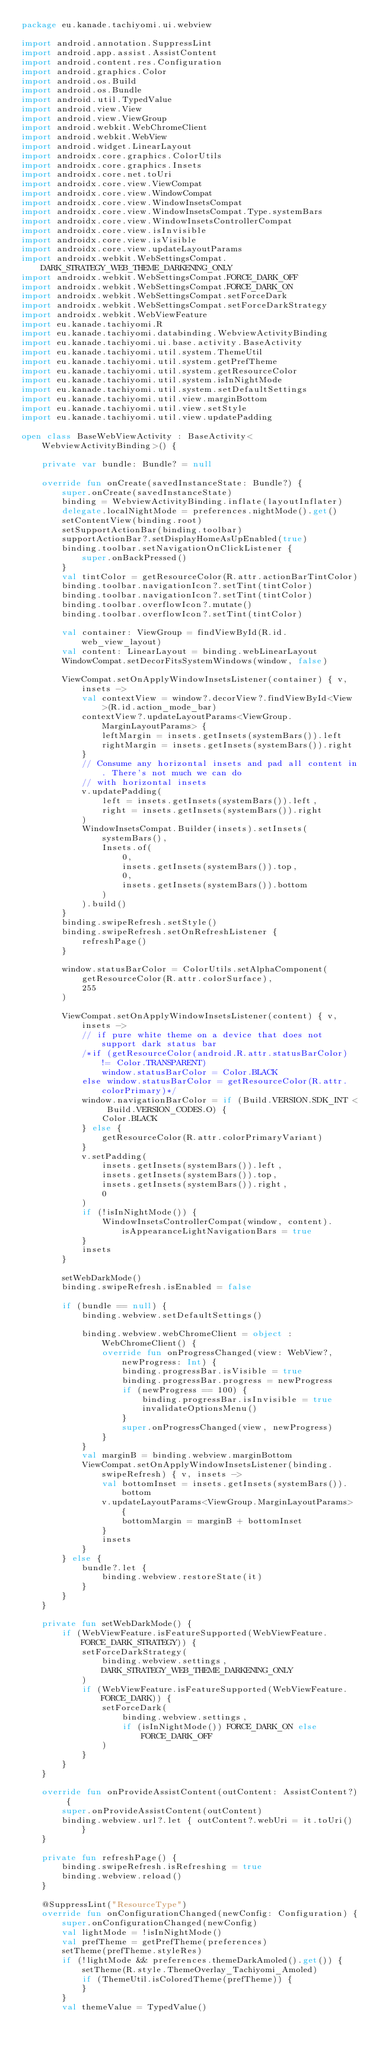<code> <loc_0><loc_0><loc_500><loc_500><_Kotlin_>package eu.kanade.tachiyomi.ui.webview

import android.annotation.SuppressLint
import android.app.assist.AssistContent
import android.content.res.Configuration
import android.graphics.Color
import android.os.Build
import android.os.Bundle
import android.util.TypedValue
import android.view.View
import android.view.ViewGroup
import android.webkit.WebChromeClient
import android.webkit.WebView
import android.widget.LinearLayout
import androidx.core.graphics.ColorUtils
import androidx.core.graphics.Insets
import androidx.core.net.toUri
import androidx.core.view.ViewCompat
import androidx.core.view.WindowCompat
import androidx.core.view.WindowInsetsCompat
import androidx.core.view.WindowInsetsCompat.Type.systemBars
import androidx.core.view.WindowInsetsControllerCompat
import androidx.core.view.isInvisible
import androidx.core.view.isVisible
import androidx.core.view.updateLayoutParams
import androidx.webkit.WebSettingsCompat.DARK_STRATEGY_WEB_THEME_DARKENING_ONLY
import androidx.webkit.WebSettingsCompat.FORCE_DARK_OFF
import androidx.webkit.WebSettingsCompat.FORCE_DARK_ON
import androidx.webkit.WebSettingsCompat.setForceDark
import androidx.webkit.WebSettingsCompat.setForceDarkStrategy
import androidx.webkit.WebViewFeature
import eu.kanade.tachiyomi.R
import eu.kanade.tachiyomi.databinding.WebviewActivityBinding
import eu.kanade.tachiyomi.ui.base.activity.BaseActivity
import eu.kanade.tachiyomi.util.system.ThemeUtil
import eu.kanade.tachiyomi.util.system.getPrefTheme
import eu.kanade.tachiyomi.util.system.getResourceColor
import eu.kanade.tachiyomi.util.system.isInNightMode
import eu.kanade.tachiyomi.util.system.setDefaultSettings
import eu.kanade.tachiyomi.util.view.marginBottom
import eu.kanade.tachiyomi.util.view.setStyle
import eu.kanade.tachiyomi.util.view.updatePadding

open class BaseWebViewActivity : BaseActivity<WebviewActivityBinding>() {

    private var bundle: Bundle? = null

    override fun onCreate(savedInstanceState: Bundle?) {
        super.onCreate(savedInstanceState)
        binding = WebviewActivityBinding.inflate(layoutInflater)
        delegate.localNightMode = preferences.nightMode().get()
        setContentView(binding.root)
        setSupportActionBar(binding.toolbar)
        supportActionBar?.setDisplayHomeAsUpEnabled(true)
        binding.toolbar.setNavigationOnClickListener {
            super.onBackPressed()
        }
        val tintColor = getResourceColor(R.attr.actionBarTintColor)
        binding.toolbar.navigationIcon?.setTint(tintColor)
        binding.toolbar.navigationIcon?.setTint(tintColor)
        binding.toolbar.overflowIcon?.mutate()
        binding.toolbar.overflowIcon?.setTint(tintColor)

        val container: ViewGroup = findViewById(R.id.web_view_layout)
        val content: LinearLayout = binding.webLinearLayout
        WindowCompat.setDecorFitsSystemWindows(window, false)

        ViewCompat.setOnApplyWindowInsetsListener(container) { v, insets ->
            val contextView = window?.decorView?.findViewById<View>(R.id.action_mode_bar)
            contextView?.updateLayoutParams<ViewGroup.MarginLayoutParams> {
                leftMargin = insets.getInsets(systemBars()).left
                rightMargin = insets.getInsets(systemBars()).right
            }
            // Consume any horizontal insets and pad all content in. There's not much we can do
            // with horizontal insets
            v.updatePadding(
                left = insets.getInsets(systemBars()).left,
                right = insets.getInsets(systemBars()).right
            )
            WindowInsetsCompat.Builder(insets).setInsets(
                systemBars(),
                Insets.of(
                    0,
                    insets.getInsets(systemBars()).top,
                    0,
                    insets.getInsets(systemBars()).bottom
                )
            ).build()
        }
        binding.swipeRefresh.setStyle()
        binding.swipeRefresh.setOnRefreshListener {
            refreshPage()
        }

        window.statusBarColor = ColorUtils.setAlphaComponent(
            getResourceColor(R.attr.colorSurface),
            255
        )

        ViewCompat.setOnApplyWindowInsetsListener(content) { v, insets ->
            // if pure white theme on a device that does not support dark status bar
            /*if (getResourceColor(android.R.attr.statusBarColor) != Color.TRANSPARENT)
                window.statusBarColor = Color.BLACK
            else window.statusBarColor = getResourceColor(R.attr.colorPrimary)*/
            window.navigationBarColor = if (Build.VERSION.SDK_INT < Build.VERSION_CODES.O) {
                Color.BLACK
            } else {
                getResourceColor(R.attr.colorPrimaryVariant)
            }
            v.setPadding(
                insets.getInsets(systemBars()).left,
                insets.getInsets(systemBars()).top,
                insets.getInsets(systemBars()).right,
                0
            )
            if (!isInNightMode()) {
                WindowInsetsControllerCompat(window, content).isAppearanceLightNavigationBars = true
            }
            insets
        }

        setWebDarkMode()
        binding.swipeRefresh.isEnabled = false

        if (bundle == null) {
            binding.webview.setDefaultSettings()

            binding.webview.webChromeClient = object : WebChromeClient() {
                override fun onProgressChanged(view: WebView?, newProgress: Int) {
                    binding.progressBar.isVisible = true
                    binding.progressBar.progress = newProgress
                    if (newProgress == 100) {
                        binding.progressBar.isInvisible = true
                        invalidateOptionsMenu()
                    }
                    super.onProgressChanged(view, newProgress)
                }
            }
            val marginB = binding.webview.marginBottom
            ViewCompat.setOnApplyWindowInsetsListener(binding.swipeRefresh) { v, insets ->
                val bottomInset = insets.getInsets(systemBars()).bottom
                v.updateLayoutParams<ViewGroup.MarginLayoutParams> {
                    bottomMargin = marginB + bottomInset
                }
                insets
            }
        } else {
            bundle?.let {
                binding.webview.restoreState(it)
            }
        }
    }

    private fun setWebDarkMode() {
        if (WebViewFeature.isFeatureSupported(WebViewFeature.FORCE_DARK_STRATEGY)) {
            setForceDarkStrategy(
                binding.webview.settings,
                DARK_STRATEGY_WEB_THEME_DARKENING_ONLY
            )
            if (WebViewFeature.isFeatureSupported(WebViewFeature.FORCE_DARK)) {
                setForceDark(
                    binding.webview.settings,
                    if (isInNightMode()) FORCE_DARK_ON else FORCE_DARK_OFF
                )
            }
        }
    }

    override fun onProvideAssistContent(outContent: AssistContent?) {
        super.onProvideAssistContent(outContent)
        binding.webview.url?.let { outContent?.webUri = it.toUri() }
    }

    private fun refreshPage() {
        binding.swipeRefresh.isRefreshing = true
        binding.webview.reload()
    }

    @SuppressLint("ResourceType")
    override fun onConfigurationChanged(newConfig: Configuration) {
        super.onConfigurationChanged(newConfig)
        val lightMode = !isInNightMode()
        val prefTheme = getPrefTheme(preferences)
        setTheme(prefTheme.styleRes)
        if (!lightMode && preferences.themeDarkAmoled().get()) {
            setTheme(R.style.ThemeOverlay_Tachiyomi_Amoled)
            if (ThemeUtil.isColoredTheme(prefTheme)) {
            }
        }
        val themeValue = TypedValue()</code> 